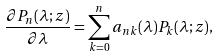Convert formula to latex. <formula><loc_0><loc_0><loc_500><loc_500>\frac { \partial P _ { n } ( \lambda ; z ) } { \partial \lambda } = \sum _ { k = 0 } ^ { n } a _ { n k } ( \lambda ) P _ { k } ( \lambda ; z ) ,</formula> 